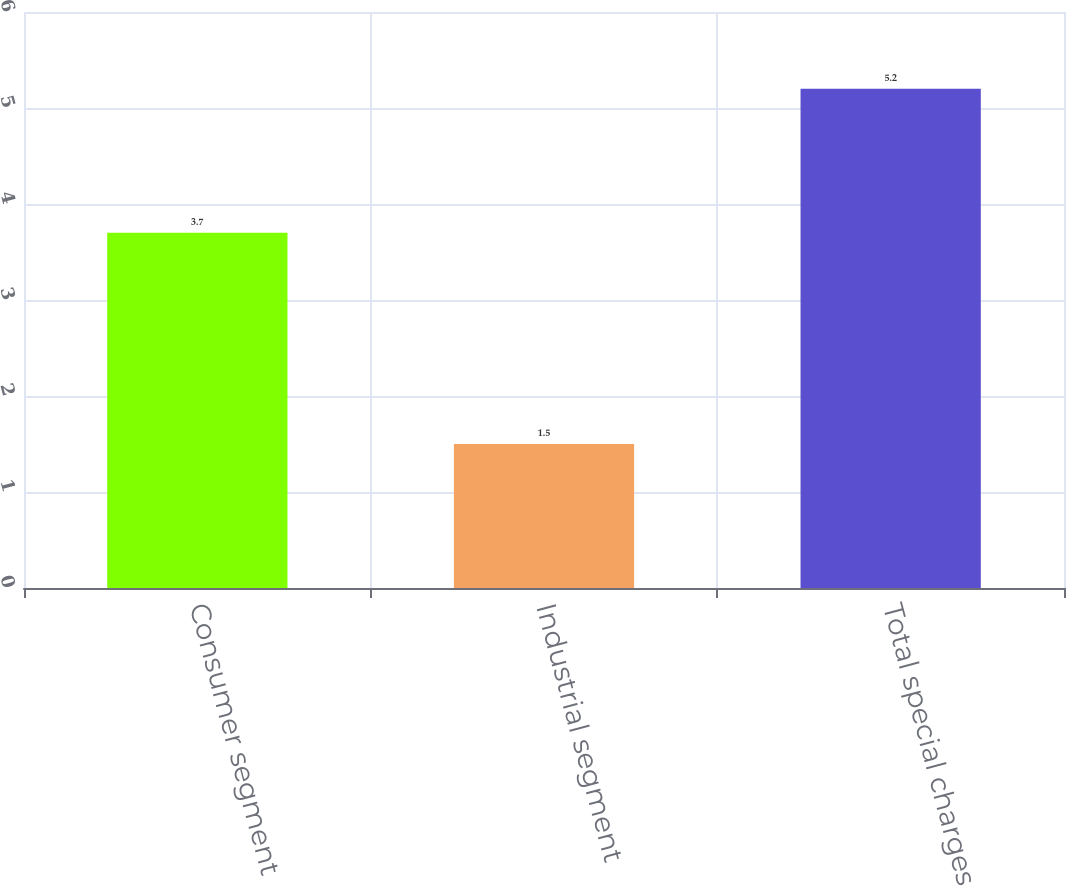Convert chart. <chart><loc_0><loc_0><loc_500><loc_500><bar_chart><fcel>Consumer segment<fcel>Industrial segment<fcel>Total special charges<nl><fcel>3.7<fcel>1.5<fcel>5.2<nl></chart> 